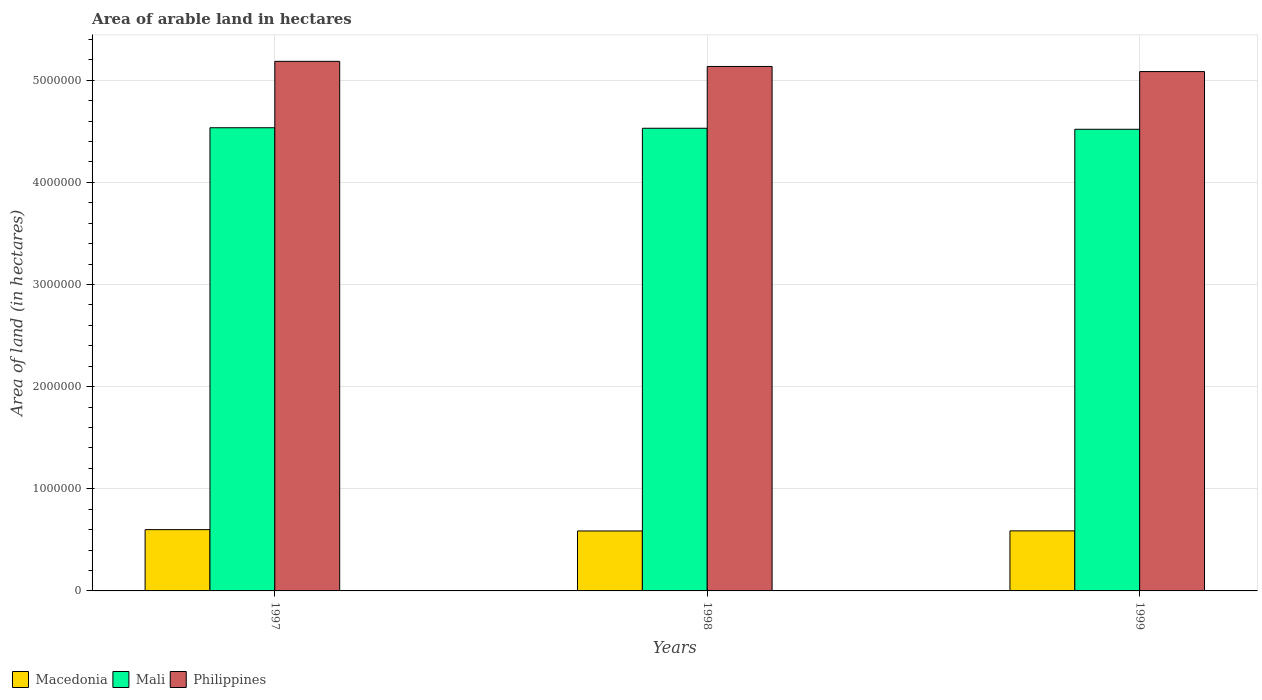How many different coloured bars are there?
Make the answer very short. 3. What is the label of the 3rd group of bars from the left?
Your answer should be compact. 1999. What is the total arable land in Macedonia in 1999?
Your response must be concise. 5.88e+05. Across all years, what is the maximum total arable land in Mali?
Provide a succinct answer. 4.54e+06. Across all years, what is the minimum total arable land in Mali?
Offer a terse response. 4.52e+06. What is the total total arable land in Philippines in the graph?
Ensure brevity in your answer.  1.54e+07. What is the difference between the total arable land in Mali in 1998 and that in 1999?
Offer a very short reply. 10000. What is the difference between the total arable land in Philippines in 1998 and the total arable land in Macedonia in 1999?
Provide a succinct answer. 4.55e+06. What is the average total arable land in Macedonia per year?
Provide a succinct answer. 5.92e+05. In the year 1998, what is the difference between the total arable land in Mali and total arable land in Philippines?
Keep it short and to the point. -6.05e+05. What is the ratio of the total arable land in Macedonia in 1998 to that in 1999?
Ensure brevity in your answer.  1. Is the total arable land in Macedonia in 1997 less than that in 1999?
Give a very brief answer. No. Is the difference between the total arable land in Mali in 1997 and 1998 greater than the difference between the total arable land in Philippines in 1997 and 1998?
Give a very brief answer. No. What is the difference between the highest and the second highest total arable land in Macedonia?
Keep it short and to the point. 1.20e+04. What is the difference between the highest and the lowest total arable land in Philippines?
Your response must be concise. 1.00e+05. What does the 3rd bar from the left in 1997 represents?
Provide a short and direct response. Philippines. What does the 3rd bar from the right in 1998 represents?
Ensure brevity in your answer.  Macedonia. Is it the case that in every year, the sum of the total arable land in Philippines and total arable land in Macedonia is greater than the total arable land in Mali?
Offer a very short reply. Yes. How many bars are there?
Your response must be concise. 9. How many years are there in the graph?
Your answer should be compact. 3. Are the values on the major ticks of Y-axis written in scientific E-notation?
Provide a short and direct response. No. Does the graph contain any zero values?
Provide a short and direct response. No. How many legend labels are there?
Ensure brevity in your answer.  3. What is the title of the graph?
Give a very brief answer. Area of arable land in hectares. Does "Europe(all income levels)" appear as one of the legend labels in the graph?
Your response must be concise. No. What is the label or title of the X-axis?
Provide a succinct answer. Years. What is the label or title of the Y-axis?
Ensure brevity in your answer.  Area of land (in hectares). What is the Area of land (in hectares) in Mali in 1997?
Make the answer very short. 4.54e+06. What is the Area of land (in hectares) in Philippines in 1997?
Offer a terse response. 5.18e+06. What is the Area of land (in hectares) in Macedonia in 1998?
Give a very brief answer. 5.87e+05. What is the Area of land (in hectares) of Mali in 1998?
Make the answer very short. 4.53e+06. What is the Area of land (in hectares) of Philippines in 1998?
Your response must be concise. 5.14e+06. What is the Area of land (in hectares) in Macedonia in 1999?
Your answer should be very brief. 5.88e+05. What is the Area of land (in hectares) in Mali in 1999?
Provide a succinct answer. 4.52e+06. What is the Area of land (in hectares) in Philippines in 1999?
Offer a very short reply. 5.08e+06. Across all years, what is the maximum Area of land (in hectares) in Mali?
Your response must be concise. 4.54e+06. Across all years, what is the maximum Area of land (in hectares) in Philippines?
Offer a very short reply. 5.18e+06. Across all years, what is the minimum Area of land (in hectares) in Macedonia?
Ensure brevity in your answer.  5.87e+05. Across all years, what is the minimum Area of land (in hectares) of Mali?
Your answer should be compact. 4.52e+06. Across all years, what is the minimum Area of land (in hectares) of Philippines?
Your answer should be very brief. 5.08e+06. What is the total Area of land (in hectares) in Macedonia in the graph?
Offer a terse response. 1.78e+06. What is the total Area of land (in hectares) of Mali in the graph?
Your answer should be compact. 1.36e+07. What is the total Area of land (in hectares) in Philippines in the graph?
Your answer should be compact. 1.54e+07. What is the difference between the Area of land (in hectares) of Macedonia in 1997 and that in 1998?
Provide a succinct answer. 1.30e+04. What is the difference between the Area of land (in hectares) of Mali in 1997 and that in 1998?
Provide a short and direct response. 5000. What is the difference between the Area of land (in hectares) of Macedonia in 1997 and that in 1999?
Give a very brief answer. 1.20e+04. What is the difference between the Area of land (in hectares) of Mali in 1997 and that in 1999?
Give a very brief answer. 1.50e+04. What is the difference between the Area of land (in hectares) of Philippines in 1997 and that in 1999?
Offer a terse response. 1.00e+05. What is the difference between the Area of land (in hectares) in Macedonia in 1998 and that in 1999?
Ensure brevity in your answer.  -1000. What is the difference between the Area of land (in hectares) of Philippines in 1998 and that in 1999?
Keep it short and to the point. 5.00e+04. What is the difference between the Area of land (in hectares) in Macedonia in 1997 and the Area of land (in hectares) in Mali in 1998?
Make the answer very short. -3.93e+06. What is the difference between the Area of land (in hectares) in Macedonia in 1997 and the Area of land (in hectares) in Philippines in 1998?
Ensure brevity in your answer.  -4.54e+06. What is the difference between the Area of land (in hectares) in Mali in 1997 and the Area of land (in hectares) in Philippines in 1998?
Provide a short and direct response. -6.00e+05. What is the difference between the Area of land (in hectares) of Macedonia in 1997 and the Area of land (in hectares) of Mali in 1999?
Provide a short and direct response. -3.92e+06. What is the difference between the Area of land (in hectares) in Macedonia in 1997 and the Area of land (in hectares) in Philippines in 1999?
Give a very brief answer. -4.48e+06. What is the difference between the Area of land (in hectares) in Mali in 1997 and the Area of land (in hectares) in Philippines in 1999?
Make the answer very short. -5.50e+05. What is the difference between the Area of land (in hectares) in Macedonia in 1998 and the Area of land (in hectares) in Mali in 1999?
Offer a terse response. -3.93e+06. What is the difference between the Area of land (in hectares) of Macedonia in 1998 and the Area of land (in hectares) of Philippines in 1999?
Offer a very short reply. -4.50e+06. What is the difference between the Area of land (in hectares) in Mali in 1998 and the Area of land (in hectares) in Philippines in 1999?
Your response must be concise. -5.55e+05. What is the average Area of land (in hectares) in Macedonia per year?
Give a very brief answer. 5.92e+05. What is the average Area of land (in hectares) of Mali per year?
Your answer should be very brief. 4.53e+06. What is the average Area of land (in hectares) of Philippines per year?
Offer a terse response. 5.14e+06. In the year 1997, what is the difference between the Area of land (in hectares) in Macedonia and Area of land (in hectares) in Mali?
Provide a short and direct response. -3.94e+06. In the year 1997, what is the difference between the Area of land (in hectares) in Macedonia and Area of land (in hectares) in Philippines?
Give a very brief answer. -4.58e+06. In the year 1997, what is the difference between the Area of land (in hectares) of Mali and Area of land (in hectares) of Philippines?
Provide a succinct answer. -6.50e+05. In the year 1998, what is the difference between the Area of land (in hectares) of Macedonia and Area of land (in hectares) of Mali?
Offer a very short reply. -3.94e+06. In the year 1998, what is the difference between the Area of land (in hectares) of Macedonia and Area of land (in hectares) of Philippines?
Keep it short and to the point. -4.55e+06. In the year 1998, what is the difference between the Area of land (in hectares) of Mali and Area of land (in hectares) of Philippines?
Make the answer very short. -6.05e+05. In the year 1999, what is the difference between the Area of land (in hectares) of Macedonia and Area of land (in hectares) of Mali?
Offer a very short reply. -3.93e+06. In the year 1999, what is the difference between the Area of land (in hectares) of Macedonia and Area of land (in hectares) of Philippines?
Keep it short and to the point. -4.50e+06. In the year 1999, what is the difference between the Area of land (in hectares) of Mali and Area of land (in hectares) of Philippines?
Your response must be concise. -5.65e+05. What is the ratio of the Area of land (in hectares) of Macedonia in 1997 to that in 1998?
Keep it short and to the point. 1.02. What is the ratio of the Area of land (in hectares) in Mali in 1997 to that in 1998?
Offer a terse response. 1. What is the ratio of the Area of land (in hectares) of Philippines in 1997 to that in 1998?
Give a very brief answer. 1.01. What is the ratio of the Area of land (in hectares) of Macedonia in 1997 to that in 1999?
Your answer should be very brief. 1.02. What is the ratio of the Area of land (in hectares) of Philippines in 1997 to that in 1999?
Provide a short and direct response. 1.02. What is the ratio of the Area of land (in hectares) in Mali in 1998 to that in 1999?
Provide a short and direct response. 1. What is the ratio of the Area of land (in hectares) of Philippines in 1998 to that in 1999?
Keep it short and to the point. 1.01. What is the difference between the highest and the second highest Area of land (in hectares) of Macedonia?
Offer a very short reply. 1.20e+04. What is the difference between the highest and the second highest Area of land (in hectares) in Mali?
Give a very brief answer. 5000. What is the difference between the highest and the lowest Area of land (in hectares) of Macedonia?
Offer a terse response. 1.30e+04. What is the difference between the highest and the lowest Area of land (in hectares) in Mali?
Give a very brief answer. 1.50e+04. 